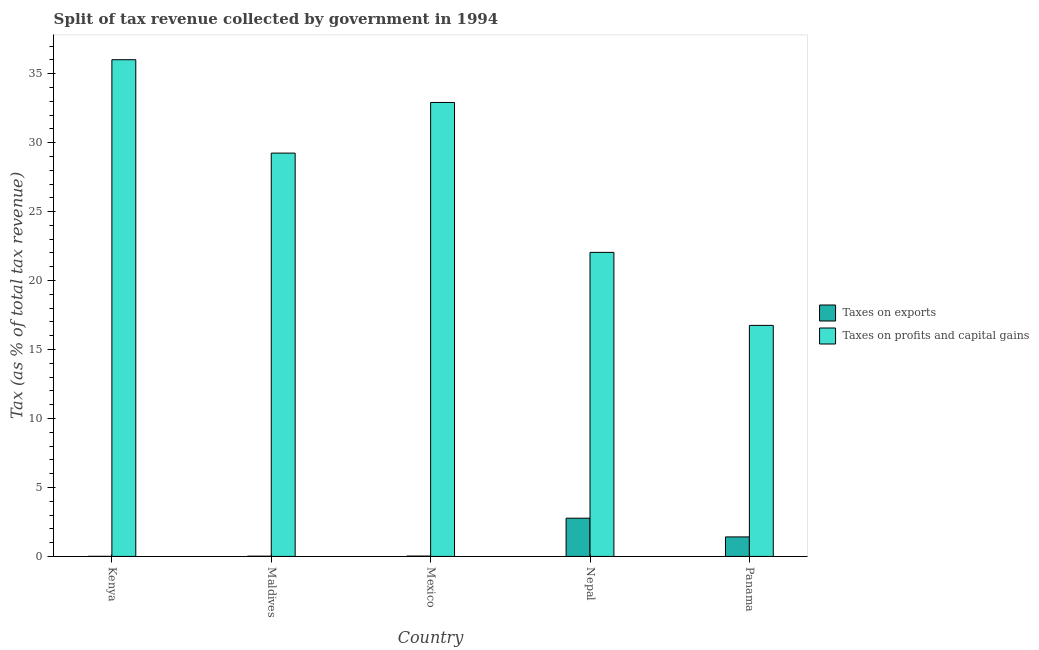How many different coloured bars are there?
Ensure brevity in your answer.  2. Are the number of bars per tick equal to the number of legend labels?
Provide a short and direct response. Yes. What is the label of the 1st group of bars from the left?
Your answer should be very brief. Kenya. In how many cases, is the number of bars for a given country not equal to the number of legend labels?
Offer a terse response. 0. What is the percentage of revenue obtained from taxes on profits and capital gains in Mexico?
Your answer should be very brief. 32.91. Across all countries, what is the maximum percentage of revenue obtained from taxes on exports?
Provide a short and direct response. 2.77. Across all countries, what is the minimum percentage of revenue obtained from taxes on profits and capital gains?
Keep it short and to the point. 16.75. In which country was the percentage of revenue obtained from taxes on exports maximum?
Your answer should be very brief. Nepal. In which country was the percentage of revenue obtained from taxes on exports minimum?
Your response must be concise. Kenya. What is the total percentage of revenue obtained from taxes on exports in the graph?
Give a very brief answer. 4.24. What is the difference between the percentage of revenue obtained from taxes on profits and capital gains in Mexico and that in Panama?
Keep it short and to the point. 16.16. What is the difference between the percentage of revenue obtained from taxes on exports in Mexico and the percentage of revenue obtained from taxes on profits and capital gains in Maldives?
Provide a short and direct response. -29.22. What is the average percentage of revenue obtained from taxes on exports per country?
Keep it short and to the point. 0.85. What is the difference between the percentage of revenue obtained from taxes on exports and percentage of revenue obtained from taxes on profits and capital gains in Nepal?
Provide a succinct answer. -19.27. What is the ratio of the percentage of revenue obtained from taxes on exports in Kenya to that in Nepal?
Offer a terse response. 0. What is the difference between the highest and the second highest percentage of revenue obtained from taxes on profits and capital gains?
Provide a succinct answer. 3.1. What is the difference between the highest and the lowest percentage of revenue obtained from taxes on exports?
Your answer should be very brief. 2.77. What does the 1st bar from the left in Panama represents?
Ensure brevity in your answer.  Taxes on exports. What does the 1st bar from the right in Panama represents?
Offer a terse response. Taxes on profits and capital gains. How many bars are there?
Ensure brevity in your answer.  10. Are all the bars in the graph horizontal?
Give a very brief answer. No. What is the difference between two consecutive major ticks on the Y-axis?
Offer a very short reply. 5. Are the values on the major ticks of Y-axis written in scientific E-notation?
Ensure brevity in your answer.  No. How many legend labels are there?
Make the answer very short. 2. How are the legend labels stacked?
Offer a terse response. Vertical. What is the title of the graph?
Make the answer very short. Split of tax revenue collected by government in 1994. What is the label or title of the X-axis?
Your answer should be compact. Country. What is the label or title of the Y-axis?
Ensure brevity in your answer.  Tax (as % of total tax revenue). What is the Tax (as % of total tax revenue) in Taxes on exports in Kenya?
Ensure brevity in your answer.  0.01. What is the Tax (as % of total tax revenue) in Taxes on profits and capital gains in Kenya?
Keep it short and to the point. 36.01. What is the Tax (as % of total tax revenue) of Taxes on exports in Maldives?
Make the answer very short. 0.02. What is the Tax (as % of total tax revenue) of Taxes on profits and capital gains in Maldives?
Ensure brevity in your answer.  29.24. What is the Tax (as % of total tax revenue) in Taxes on exports in Mexico?
Provide a succinct answer. 0.03. What is the Tax (as % of total tax revenue) of Taxes on profits and capital gains in Mexico?
Keep it short and to the point. 32.91. What is the Tax (as % of total tax revenue) in Taxes on exports in Nepal?
Keep it short and to the point. 2.77. What is the Tax (as % of total tax revenue) of Taxes on profits and capital gains in Nepal?
Your answer should be compact. 22.04. What is the Tax (as % of total tax revenue) in Taxes on exports in Panama?
Your answer should be compact. 1.41. What is the Tax (as % of total tax revenue) of Taxes on profits and capital gains in Panama?
Provide a succinct answer. 16.75. Across all countries, what is the maximum Tax (as % of total tax revenue) in Taxes on exports?
Provide a short and direct response. 2.77. Across all countries, what is the maximum Tax (as % of total tax revenue) of Taxes on profits and capital gains?
Your answer should be compact. 36.01. Across all countries, what is the minimum Tax (as % of total tax revenue) of Taxes on exports?
Offer a very short reply. 0.01. Across all countries, what is the minimum Tax (as % of total tax revenue) in Taxes on profits and capital gains?
Keep it short and to the point. 16.75. What is the total Tax (as % of total tax revenue) of Taxes on exports in the graph?
Offer a very short reply. 4.24. What is the total Tax (as % of total tax revenue) of Taxes on profits and capital gains in the graph?
Offer a terse response. 136.96. What is the difference between the Tax (as % of total tax revenue) in Taxes on exports in Kenya and that in Maldives?
Your answer should be compact. -0.01. What is the difference between the Tax (as % of total tax revenue) in Taxes on profits and capital gains in Kenya and that in Maldives?
Keep it short and to the point. 6.77. What is the difference between the Tax (as % of total tax revenue) of Taxes on exports in Kenya and that in Mexico?
Your answer should be very brief. -0.02. What is the difference between the Tax (as % of total tax revenue) in Taxes on profits and capital gains in Kenya and that in Mexico?
Offer a terse response. 3.1. What is the difference between the Tax (as % of total tax revenue) in Taxes on exports in Kenya and that in Nepal?
Offer a very short reply. -2.77. What is the difference between the Tax (as % of total tax revenue) of Taxes on profits and capital gains in Kenya and that in Nepal?
Give a very brief answer. 13.97. What is the difference between the Tax (as % of total tax revenue) of Taxes on exports in Kenya and that in Panama?
Offer a terse response. -1.41. What is the difference between the Tax (as % of total tax revenue) of Taxes on profits and capital gains in Kenya and that in Panama?
Your answer should be compact. 19.26. What is the difference between the Tax (as % of total tax revenue) of Taxes on exports in Maldives and that in Mexico?
Provide a succinct answer. -0.01. What is the difference between the Tax (as % of total tax revenue) in Taxes on profits and capital gains in Maldives and that in Mexico?
Your response must be concise. -3.67. What is the difference between the Tax (as % of total tax revenue) of Taxes on exports in Maldives and that in Nepal?
Offer a very short reply. -2.75. What is the difference between the Tax (as % of total tax revenue) of Taxes on profits and capital gains in Maldives and that in Nepal?
Make the answer very short. 7.2. What is the difference between the Tax (as % of total tax revenue) of Taxes on exports in Maldives and that in Panama?
Offer a terse response. -1.4. What is the difference between the Tax (as % of total tax revenue) in Taxes on profits and capital gains in Maldives and that in Panama?
Provide a short and direct response. 12.49. What is the difference between the Tax (as % of total tax revenue) of Taxes on exports in Mexico and that in Nepal?
Ensure brevity in your answer.  -2.75. What is the difference between the Tax (as % of total tax revenue) of Taxes on profits and capital gains in Mexico and that in Nepal?
Keep it short and to the point. 10.87. What is the difference between the Tax (as % of total tax revenue) in Taxes on exports in Mexico and that in Panama?
Your answer should be very brief. -1.39. What is the difference between the Tax (as % of total tax revenue) of Taxes on profits and capital gains in Mexico and that in Panama?
Make the answer very short. 16.16. What is the difference between the Tax (as % of total tax revenue) in Taxes on exports in Nepal and that in Panama?
Your answer should be very brief. 1.36. What is the difference between the Tax (as % of total tax revenue) of Taxes on profits and capital gains in Nepal and that in Panama?
Keep it short and to the point. 5.29. What is the difference between the Tax (as % of total tax revenue) in Taxes on exports in Kenya and the Tax (as % of total tax revenue) in Taxes on profits and capital gains in Maldives?
Provide a short and direct response. -29.24. What is the difference between the Tax (as % of total tax revenue) in Taxes on exports in Kenya and the Tax (as % of total tax revenue) in Taxes on profits and capital gains in Mexico?
Provide a short and direct response. -32.91. What is the difference between the Tax (as % of total tax revenue) of Taxes on exports in Kenya and the Tax (as % of total tax revenue) of Taxes on profits and capital gains in Nepal?
Your answer should be compact. -22.04. What is the difference between the Tax (as % of total tax revenue) of Taxes on exports in Kenya and the Tax (as % of total tax revenue) of Taxes on profits and capital gains in Panama?
Your answer should be very brief. -16.74. What is the difference between the Tax (as % of total tax revenue) in Taxes on exports in Maldives and the Tax (as % of total tax revenue) in Taxes on profits and capital gains in Mexico?
Your response must be concise. -32.89. What is the difference between the Tax (as % of total tax revenue) of Taxes on exports in Maldives and the Tax (as % of total tax revenue) of Taxes on profits and capital gains in Nepal?
Offer a terse response. -22.02. What is the difference between the Tax (as % of total tax revenue) of Taxes on exports in Maldives and the Tax (as % of total tax revenue) of Taxes on profits and capital gains in Panama?
Give a very brief answer. -16.73. What is the difference between the Tax (as % of total tax revenue) of Taxes on exports in Mexico and the Tax (as % of total tax revenue) of Taxes on profits and capital gains in Nepal?
Provide a short and direct response. -22.02. What is the difference between the Tax (as % of total tax revenue) in Taxes on exports in Mexico and the Tax (as % of total tax revenue) in Taxes on profits and capital gains in Panama?
Offer a terse response. -16.72. What is the difference between the Tax (as % of total tax revenue) of Taxes on exports in Nepal and the Tax (as % of total tax revenue) of Taxes on profits and capital gains in Panama?
Offer a very short reply. -13.98. What is the average Tax (as % of total tax revenue) of Taxes on exports per country?
Keep it short and to the point. 0.85. What is the average Tax (as % of total tax revenue) of Taxes on profits and capital gains per country?
Your response must be concise. 27.39. What is the difference between the Tax (as % of total tax revenue) in Taxes on exports and Tax (as % of total tax revenue) in Taxes on profits and capital gains in Kenya?
Your response must be concise. -36.01. What is the difference between the Tax (as % of total tax revenue) in Taxes on exports and Tax (as % of total tax revenue) in Taxes on profits and capital gains in Maldives?
Your response must be concise. -29.22. What is the difference between the Tax (as % of total tax revenue) of Taxes on exports and Tax (as % of total tax revenue) of Taxes on profits and capital gains in Mexico?
Ensure brevity in your answer.  -32.89. What is the difference between the Tax (as % of total tax revenue) of Taxes on exports and Tax (as % of total tax revenue) of Taxes on profits and capital gains in Nepal?
Offer a terse response. -19.27. What is the difference between the Tax (as % of total tax revenue) of Taxes on exports and Tax (as % of total tax revenue) of Taxes on profits and capital gains in Panama?
Your answer should be compact. -15.34. What is the ratio of the Tax (as % of total tax revenue) of Taxes on exports in Kenya to that in Maldives?
Offer a very short reply. 0.36. What is the ratio of the Tax (as % of total tax revenue) of Taxes on profits and capital gains in Kenya to that in Maldives?
Offer a very short reply. 1.23. What is the ratio of the Tax (as % of total tax revenue) of Taxes on exports in Kenya to that in Mexico?
Give a very brief answer. 0.25. What is the ratio of the Tax (as % of total tax revenue) in Taxes on profits and capital gains in Kenya to that in Mexico?
Ensure brevity in your answer.  1.09. What is the ratio of the Tax (as % of total tax revenue) in Taxes on exports in Kenya to that in Nepal?
Give a very brief answer. 0. What is the ratio of the Tax (as % of total tax revenue) in Taxes on profits and capital gains in Kenya to that in Nepal?
Ensure brevity in your answer.  1.63. What is the ratio of the Tax (as % of total tax revenue) in Taxes on exports in Kenya to that in Panama?
Offer a terse response. 0. What is the ratio of the Tax (as % of total tax revenue) in Taxes on profits and capital gains in Kenya to that in Panama?
Your response must be concise. 2.15. What is the ratio of the Tax (as % of total tax revenue) of Taxes on exports in Maldives to that in Mexico?
Make the answer very short. 0.71. What is the ratio of the Tax (as % of total tax revenue) in Taxes on profits and capital gains in Maldives to that in Mexico?
Provide a short and direct response. 0.89. What is the ratio of the Tax (as % of total tax revenue) in Taxes on exports in Maldives to that in Nepal?
Provide a short and direct response. 0.01. What is the ratio of the Tax (as % of total tax revenue) of Taxes on profits and capital gains in Maldives to that in Nepal?
Offer a terse response. 1.33. What is the ratio of the Tax (as % of total tax revenue) of Taxes on exports in Maldives to that in Panama?
Make the answer very short. 0.01. What is the ratio of the Tax (as % of total tax revenue) of Taxes on profits and capital gains in Maldives to that in Panama?
Provide a short and direct response. 1.75. What is the ratio of the Tax (as % of total tax revenue) of Taxes on exports in Mexico to that in Nepal?
Provide a succinct answer. 0.01. What is the ratio of the Tax (as % of total tax revenue) in Taxes on profits and capital gains in Mexico to that in Nepal?
Your response must be concise. 1.49. What is the ratio of the Tax (as % of total tax revenue) of Taxes on exports in Mexico to that in Panama?
Make the answer very short. 0.02. What is the ratio of the Tax (as % of total tax revenue) in Taxes on profits and capital gains in Mexico to that in Panama?
Your response must be concise. 1.96. What is the ratio of the Tax (as % of total tax revenue) of Taxes on exports in Nepal to that in Panama?
Your answer should be very brief. 1.96. What is the ratio of the Tax (as % of total tax revenue) of Taxes on profits and capital gains in Nepal to that in Panama?
Ensure brevity in your answer.  1.32. What is the difference between the highest and the second highest Tax (as % of total tax revenue) in Taxes on exports?
Keep it short and to the point. 1.36. What is the difference between the highest and the second highest Tax (as % of total tax revenue) in Taxes on profits and capital gains?
Make the answer very short. 3.1. What is the difference between the highest and the lowest Tax (as % of total tax revenue) in Taxes on exports?
Give a very brief answer. 2.77. What is the difference between the highest and the lowest Tax (as % of total tax revenue) of Taxes on profits and capital gains?
Offer a terse response. 19.26. 